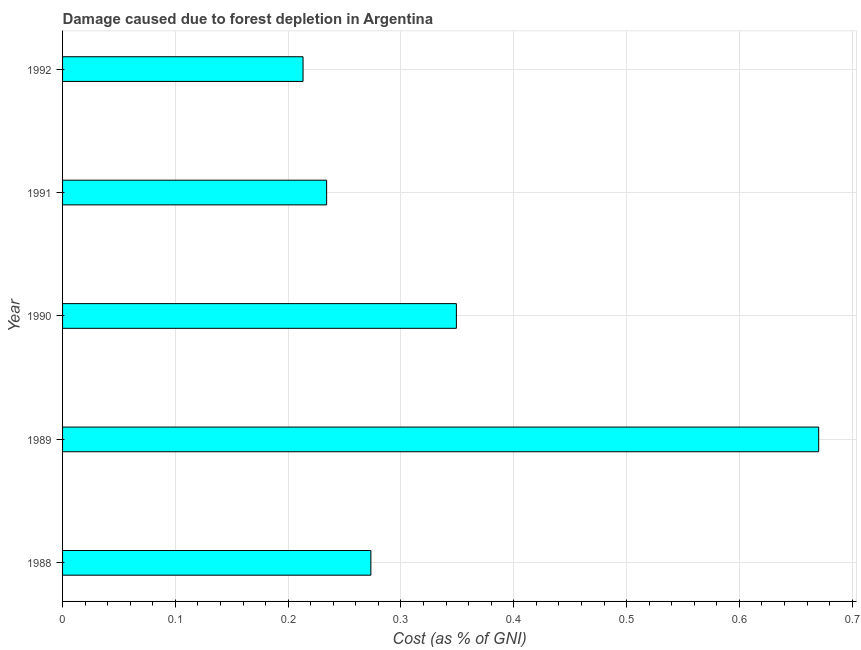Does the graph contain grids?
Make the answer very short. Yes. What is the title of the graph?
Your response must be concise. Damage caused due to forest depletion in Argentina. What is the label or title of the X-axis?
Keep it short and to the point. Cost (as % of GNI). What is the label or title of the Y-axis?
Your answer should be very brief. Year. What is the damage caused due to forest depletion in 1989?
Provide a short and direct response. 0.67. Across all years, what is the maximum damage caused due to forest depletion?
Provide a succinct answer. 0.67. Across all years, what is the minimum damage caused due to forest depletion?
Your response must be concise. 0.21. In which year was the damage caused due to forest depletion minimum?
Give a very brief answer. 1992. What is the sum of the damage caused due to forest depletion?
Offer a very short reply. 1.74. What is the difference between the damage caused due to forest depletion in 1988 and 1991?
Ensure brevity in your answer.  0.04. What is the average damage caused due to forest depletion per year?
Provide a succinct answer. 0.35. What is the median damage caused due to forest depletion?
Offer a very short reply. 0.27. In how many years, is the damage caused due to forest depletion greater than 0.08 %?
Offer a terse response. 5. Do a majority of the years between 1992 and 1988 (inclusive) have damage caused due to forest depletion greater than 0.66 %?
Give a very brief answer. Yes. What is the ratio of the damage caused due to forest depletion in 1988 to that in 1992?
Your response must be concise. 1.28. Is the damage caused due to forest depletion in 1991 less than that in 1992?
Keep it short and to the point. No. Is the difference between the damage caused due to forest depletion in 1991 and 1992 greater than the difference between any two years?
Your answer should be compact. No. What is the difference between the highest and the second highest damage caused due to forest depletion?
Provide a succinct answer. 0.32. Is the sum of the damage caused due to forest depletion in 1989 and 1991 greater than the maximum damage caused due to forest depletion across all years?
Give a very brief answer. Yes. What is the difference between the highest and the lowest damage caused due to forest depletion?
Offer a terse response. 0.46. How many bars are there?
Your response must be concise. 5. How many years are there in the graph?
Ensure brevity in your answer.  5. What is the difference between two consecutive major ticks on the X-axis?
Provide a succinct answer. 0.1. Are the values on the major ticks of X-axis written in scientific E-notation?
Your answer should be compact. No. What is the Cost (as % of GNI) in 1988?
Offer a very short reply. 0.27. What is the Cost (as % of GNI) in 1989?
Provide a short and direct response. 0.67. What is the Cost (as % of GNI) of 1990?
Offer a very short reply. 0.35. What is the Cost (as % of GNI) in 1991?
Ensure brevity in your answer.  0.23. What is the Cost (as % of GNI) of 1992?
Offer a terse response. 0.21. What is the difference between the Cost (as % of GNI) in 1988 and 1989?
Make the answer very short. -0.4. What is the difference between the Cost (as % of GNI) in 1988 and 1990?
Offer a terse response. -0.08. What is the difference between the Cost (as % of GNI) in 1988 and 1991?
Give a very brief answer. 0.04. What is the difference between the Cost (as % of GNI) in 1988 and 1992?
Offer a terse response. 0.06. What is the difference between the Cost (as % of GNI) in 1989 and 1990?
Make the answer very short. 0.32. What is the difference between the Cost (as % of GNI) in 1989 and 1991?
Your response must be concise. 0.44. What is the difference between the Cost (as % of GNI) in 1989 and 1992?
Provide a succinct answer. 0.46. What is the difference between the Cost (as % of GNI) in 1990 and 1991?
Provide a succinct answer. 0.12. What is the difference between the Cost (as % of GNI) in 1990 and 1992?
Keep it short and to the point. 0.14. What is the difference between the Cost (as % of GNI) in 1991 and 1992?
Ensure brevity in your answer.  0.02. What is the ratio of the Cost (as % of GNI) in 1988 to that in 1989?
Provide a short and direct response. 0.41. What is the ratio of the Cost (as % of GNI) in 1988 to that in 1990?
Provide a short and direct response. 0.78. What is the ratio of the Cost (as % of GNI) in 1988 to that in 1991?
Your answer should be compact. 1.17. What is the ratio of the Cost (as % of GNI) in 1988 to that in 1992?
Provide a succinct answer. 1.28. What is the ratio of the Cost (as % of GNI) in 1989 to that in 1990?
Make the answer very short. 1.92. What is the ratio of the Cost (as % of GNI) in 1989 to that in 1991?
Offer a terse response. 2.86. What is the ratio of the Cost (as % of GNI) in 1989 to that in 1992?
Your answer should be very brief. 3.14. What is the ratio of the Cost (as % of GNI) in 1990 to that in 1991?
Keep it short and to the point. 1.49. What is the ratio of the Cost (as % of GNI) in 1990 to that in 1992?
Ensure brevity in your answer.  1.64. What is the ratio of the Cost (as % of GNI) in 1991 to that in 1992?
Keep it short and to the point. 1.1. 